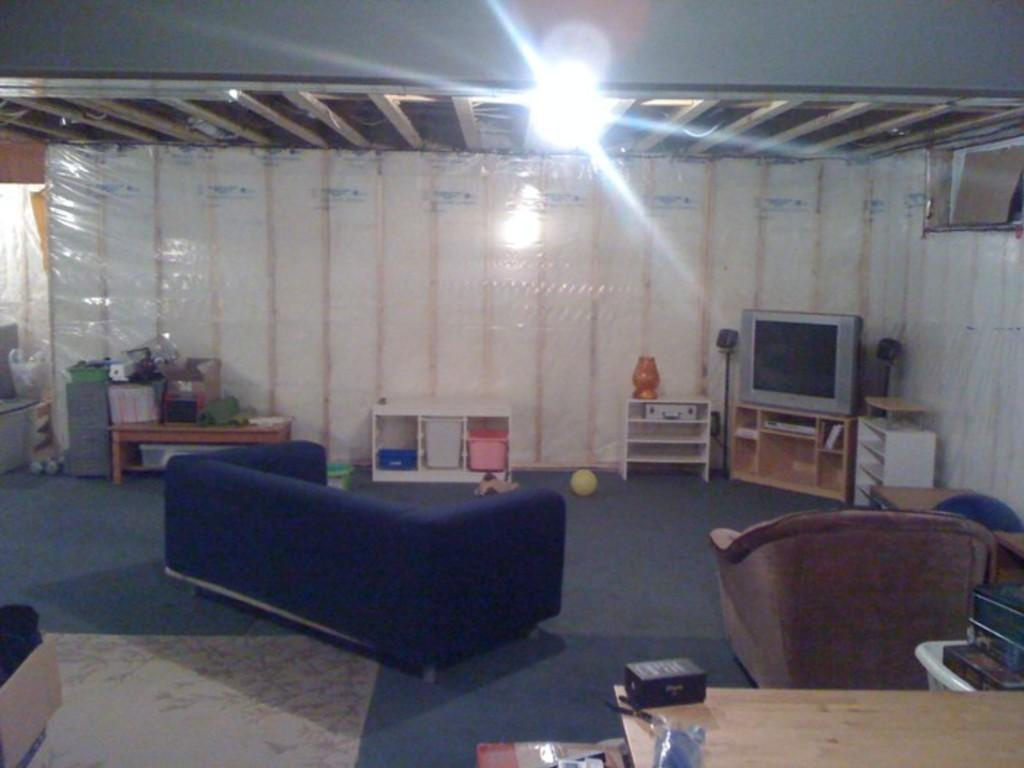What type of structure can be seen in the image? There is a wall in the image. What can be used for illumination in the image? There is a light in the image. What type of electronic device is present in the image? There is a television in the image. What can be used for storage in the image? There are shelves in the image. What can be used for placing objects in the image? There are tables in the image. What type of seating is available in the image? There are sofas in the image. What type of furniture is present for sitting in the image? There is a chair in the image. Can you see any crayons on the shelves in the image? There is no mention of crayons in the provided facts, so we cannot determine if they are present in the image. Is there a knot tied in the chair in the image? There is no mention of a knot in the provided facts, so we cannot determine if it is present in the image. 